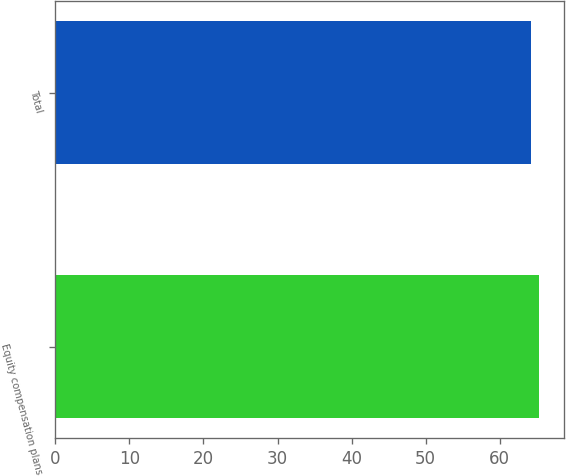Convert chart to OTSL. <chart><loc_0><loc_0><loc_500><loc_500><bar_chart><fcel>Equity compensation plans<fcel>Total<nl><fcel>65.37<fcel>64.22<nl></chart> 